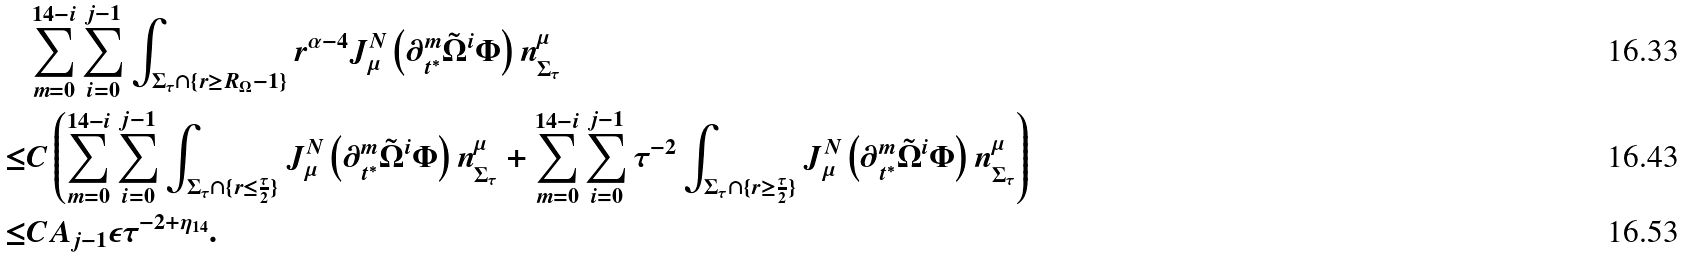<formula> <loc_0><loc_0><loc_500><loc_500>& \sum _ { m = 0 } ^ { 1 4 - i } \sum _ { i = 0 } ^ { j - 1 } \int _ { \Sigma _ { \tau } \cap \{ r \geq R _ { \Omega } - 1 \} } r ^ { \alpha - 4 } J ^ { N } _ { \mu } \left ( \partial _ { t ^ { * } } ^ { m } \tilde { \Omega } ^ { i } \Phi \right ) n ^ { \mu } _ { \Sigma _ { \tau } } \\ \leq & C \left ( \sum _ { m = 0 } ^ { 1 4 - i } \sum _ { i = 0 } ^ { j - 1 } \int _ { \Sigma _ { \tau } \cap \{ r \leq \frac { \tau } { 2 } \} } J ^ { N } _ { \mu } \left ( \partial _ { t ^ { * } } ^ { m } \tilde { \Omega } ^ { i } \Phi \right ) n ^ { \mu } _ { \Sigma _ { \tau } } + \sum _ { m = 0 } ^ { 1 4 - i } \sum _ { i = 0 } ^ { j - 1 } \tau ^ { - 2 } \int _ { \Sigma _ { \tau } \cap \{ r \geq \frac { \tau } { 2 } \} } J ^ { N } _ { \mu } \left ( \partial _ { t ^ { * } } ^ { m } \tilde { \Omega } ^ { i } \Phi \right ) n ^ { \mu } _ { \Sigma _ { \tau } } \right ) \\ \leq & C A _ { j - 1 } \epsilon \tau ^ { - 2 + \eta _ { 1 4 } } .</formula> 